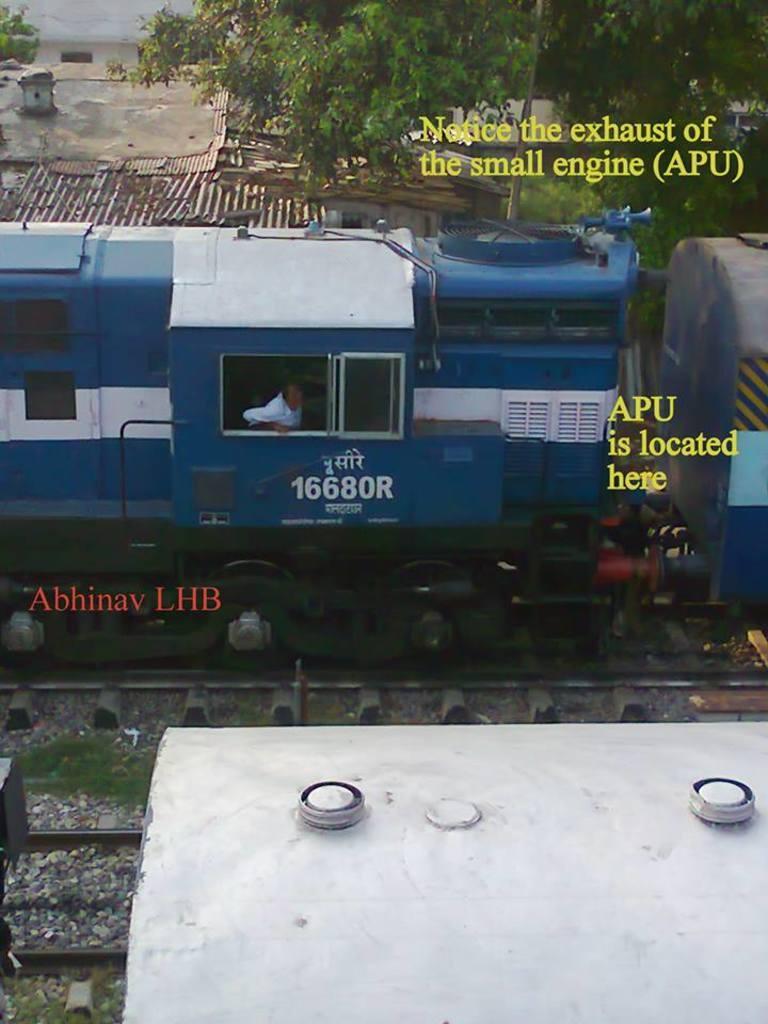Could you give a brief overview of what you see in this image? In this image we can see a blue color train is on the railway track. background of the image houses and trees are present and on the image some text is written. 